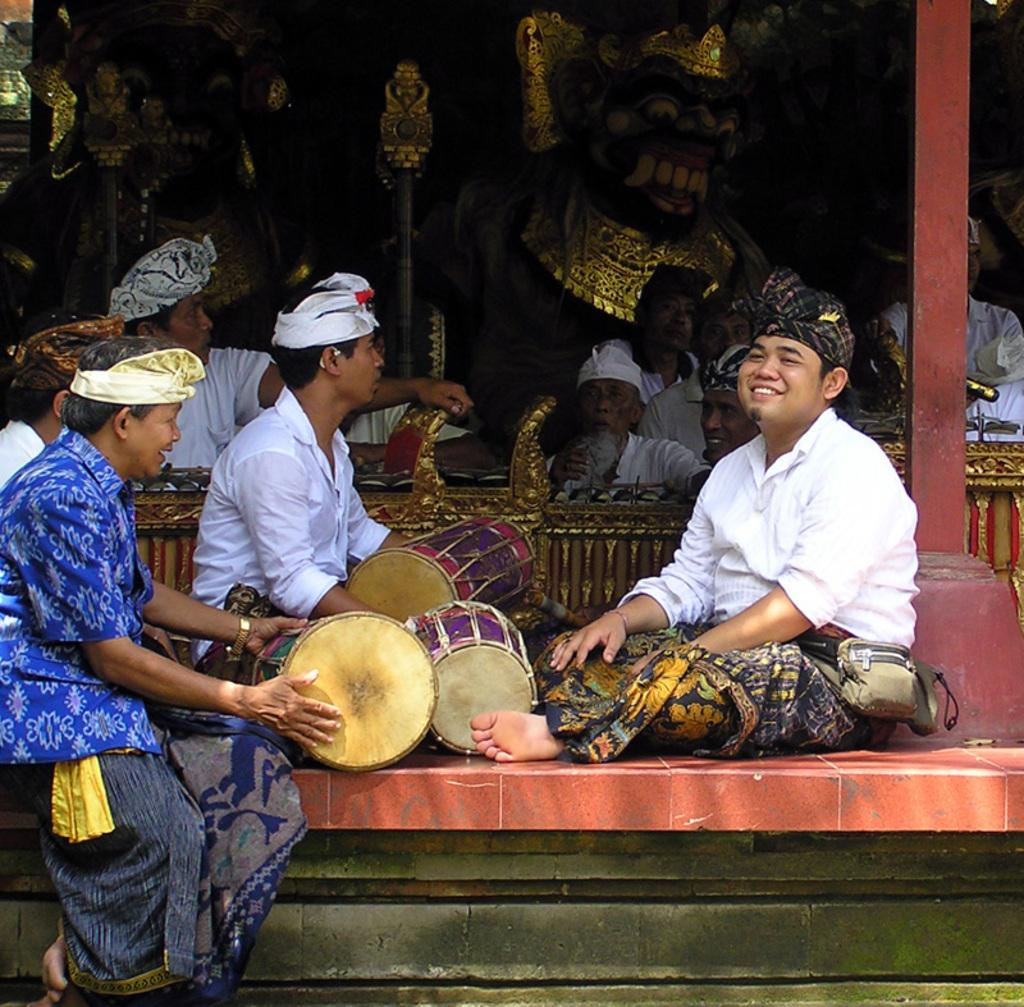How many people are in the image? There are many people in the image. What are the people doing in the image? The people are sitting and playing musical instruments. What type of goat can be seen playing a musical instrument in the image? There is no goat present in the image, and therefore no such activity can be observed. 